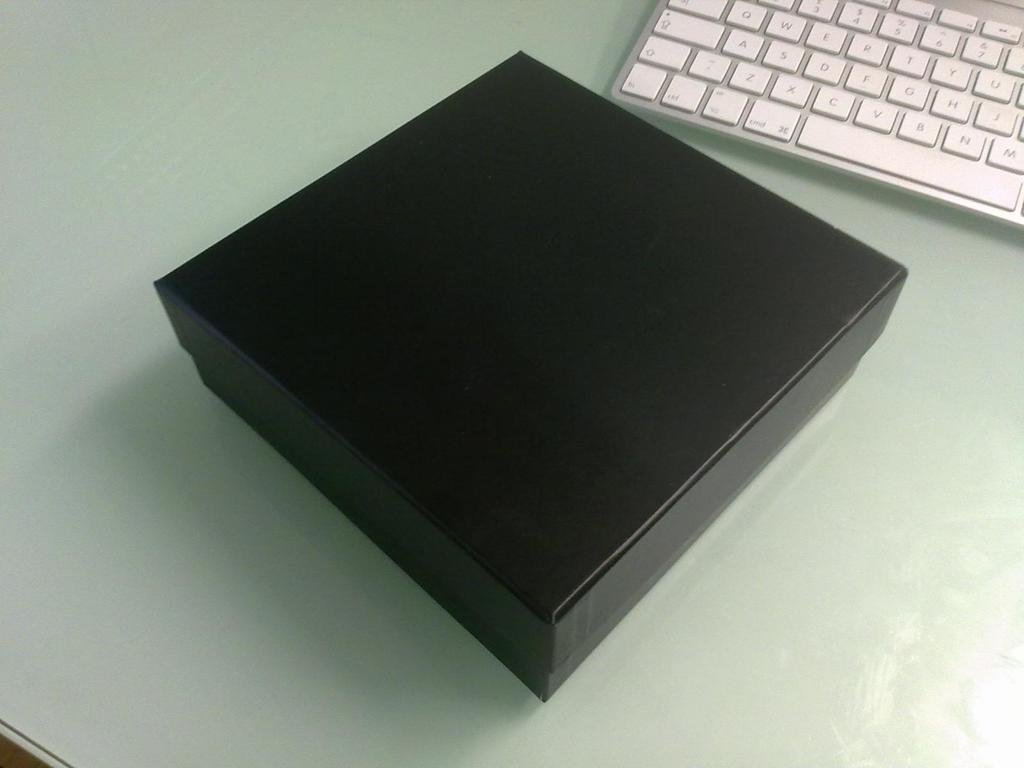<image>
Render a clear and concise summary of the photo. A square brown box sits next to a silver keyboard, near the cmd key and spacebar. 